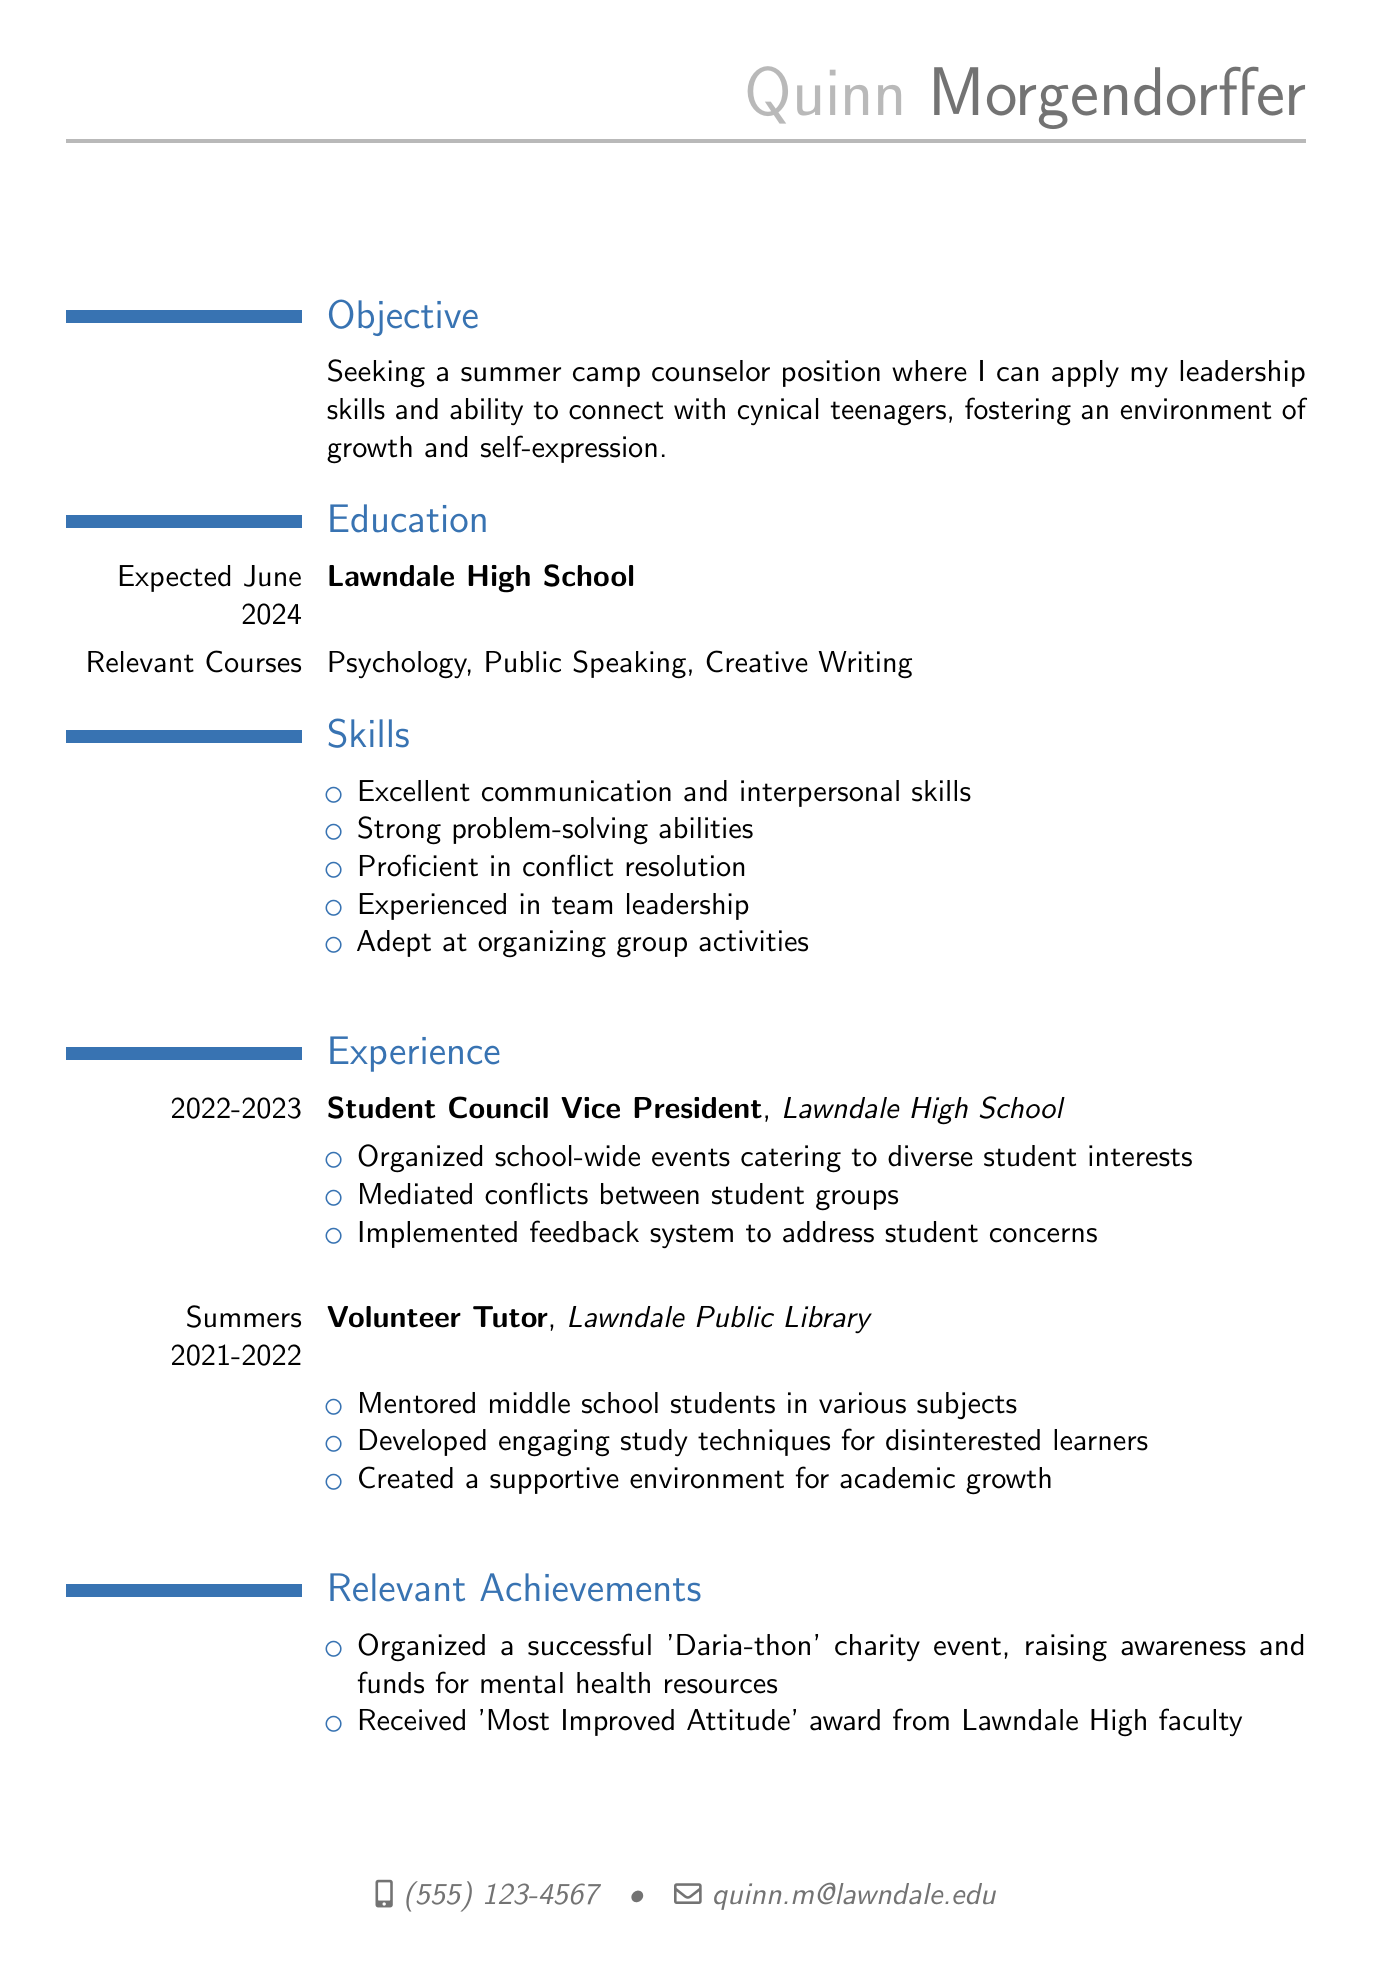What is the candidate's name? The name of the candidate is stated at the top of the document.
Answer: Quinn Morgendorffer What is the contact email? The email is provided in the personal information section.
Answer: quinn.m@lawndale.edu What is the expected graduation date? The graduation date is mentioned under the education section.
Answer: Expected June 2024 Which position did Quinn hold at Lawndale High School in 2022-2023? The position is listed under the experience section.
Answer: Student Council Vice President What skill is emphasized in the objective? The objective mentions specifically how the candidate aims to relate to a specific demographic group.
Answer: Connect with cynical teenagers How many summers did Quinn volunteer at the library? The duration of the volunteer work is mentioned alongside the job title under experience.
Answer: Two summers What unique event did Quinn organize? The relevant achievement section lists a notable event organized by Quinn.
Answer: 'Daria-thon' charity event What award did Quinn receive from the faculty? The relevant achievements section includes information about recognition received.
Answer: 'Most Improved Attitude' award Which subject did Quinn tutor in? The tutoring responsibilities detail which level of students were mentored.
Answer: Various subjects 